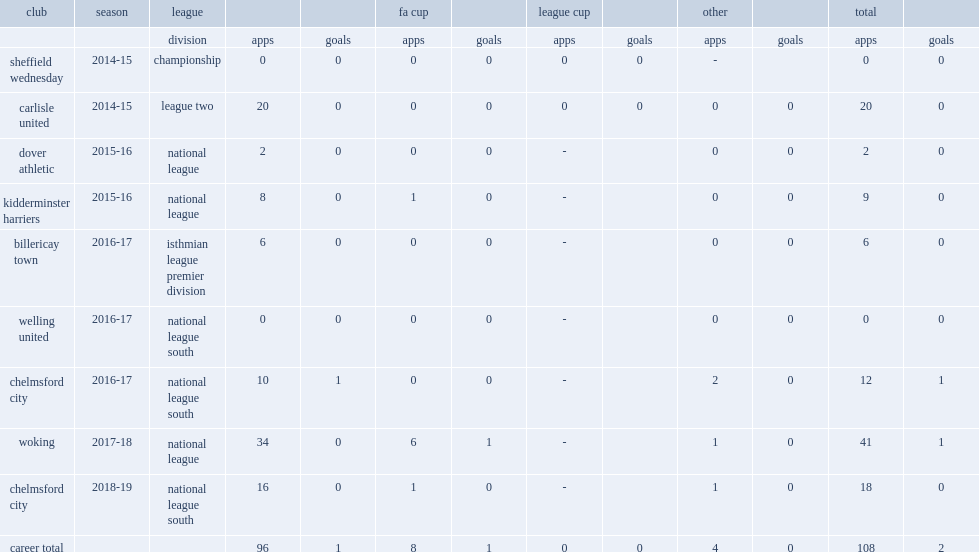Which club did matt young join in the 2016-17 isthmian league premier division, making six appearances? Billericay town. 